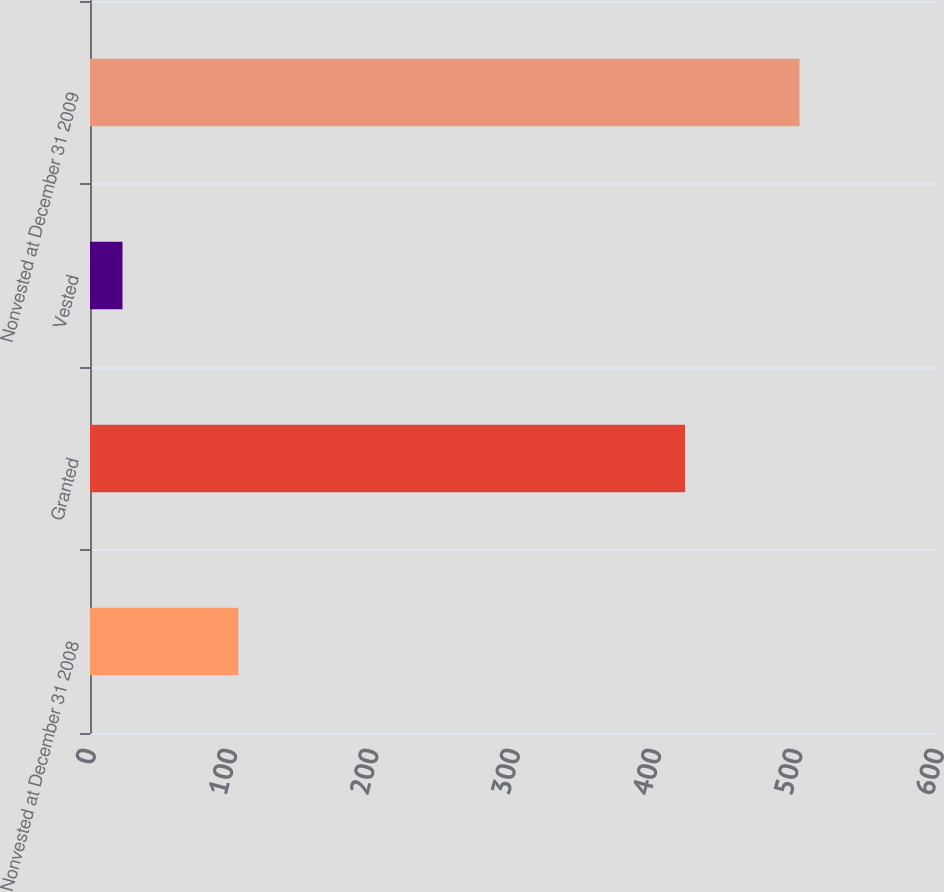<chart> <loc_0><loc_0><loc_500><loc_500><bar_chart><fcel>Nonvested at December 31 2008<fcel>Granted<fcel>Vested<fcel>Nonvested at December 31 2009<nl><fcel>105<fcel>421<fcel>23<fcel>502<nl></chart> 